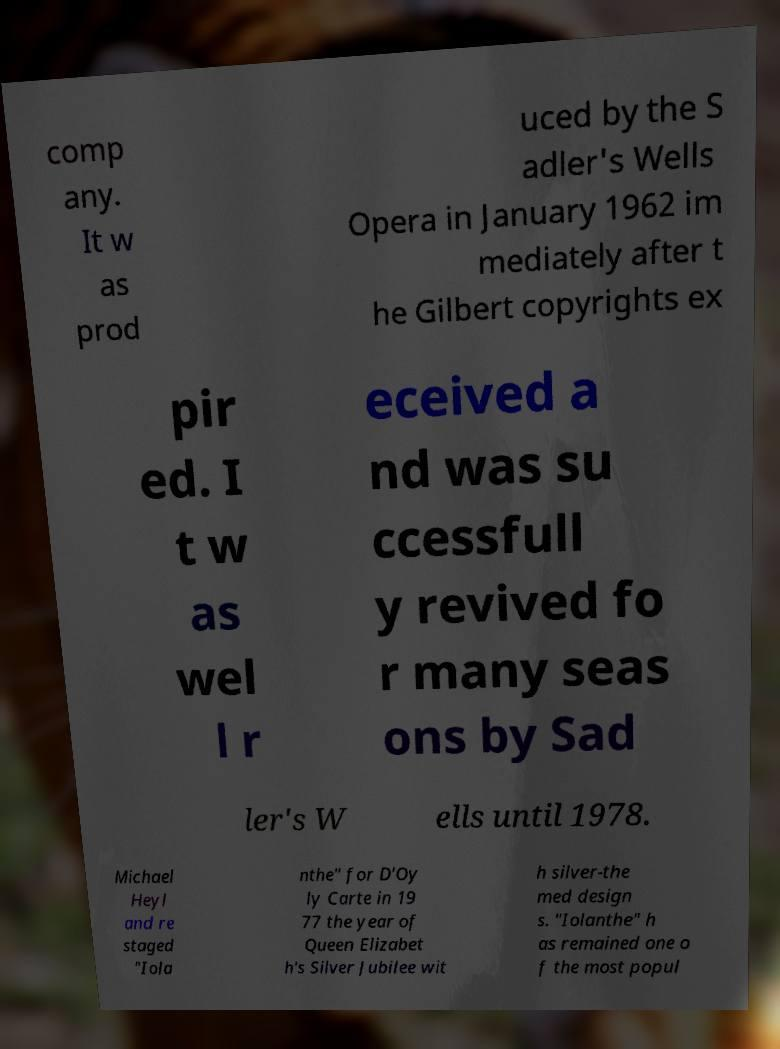Please identify and transcribe the text found in this image. comp any. It w as prod uced by the S adler's Wells Opera in January 1962 im mediately after t he Gilbert copyrights ex pir ed. I t w as wel l r eceived a nd was su ccessfull y revived fo r many seas ons by Sad ler's W ells until 1978. Michael Heyl and re staged "Iola nthe" for D'Oy ly Carte in 19 77 the year of Queen Elizabet h's Silver Jubilee wit h silver-the med design s. "Iolanthe" h as remained one o f the most popul 